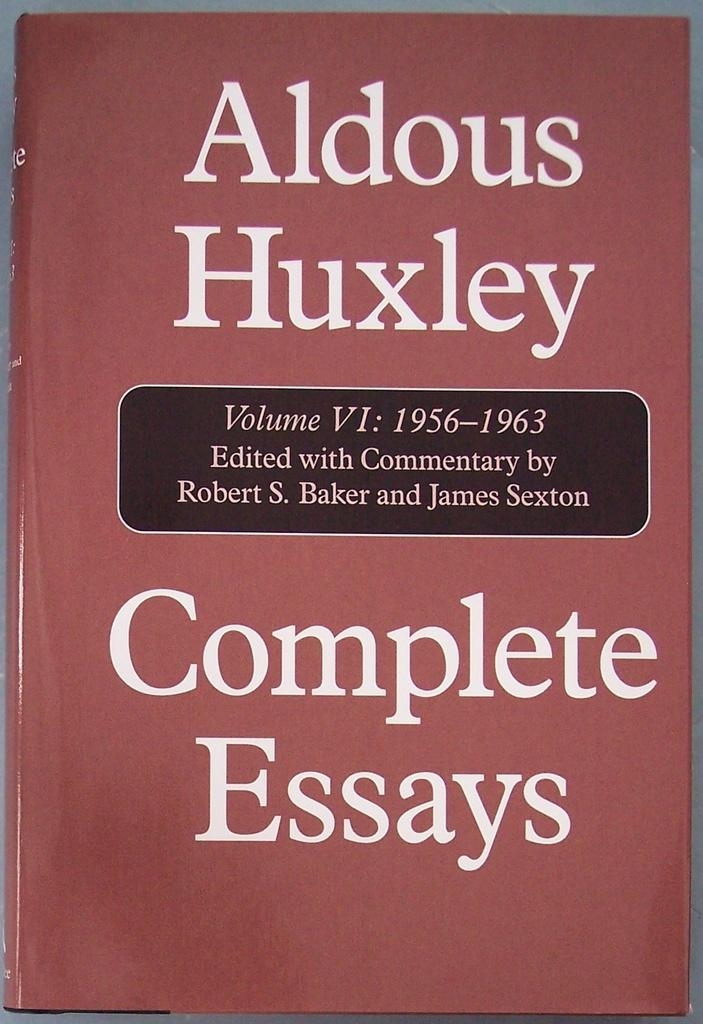<image>
Render a clear and concise summary of the photo. a book with complete essays inside of it 